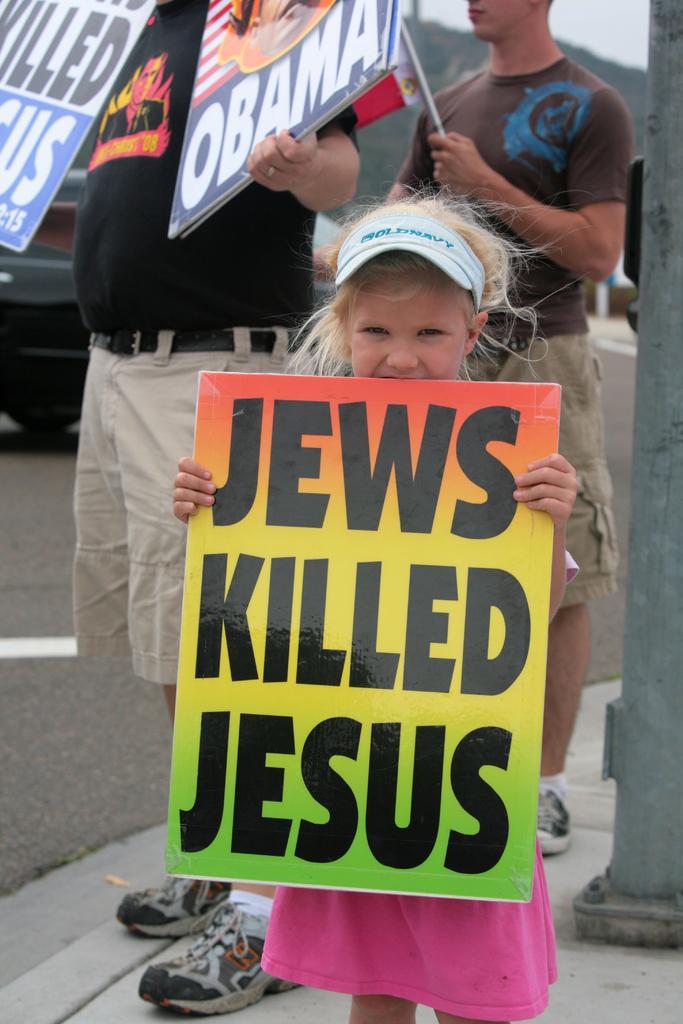Could you give a brief overview of what you see in this image? In the image we can see a girl and two men standing, wearing clothes and shoes. These are the posters, road, vehicle on the road, pole and a sky. 